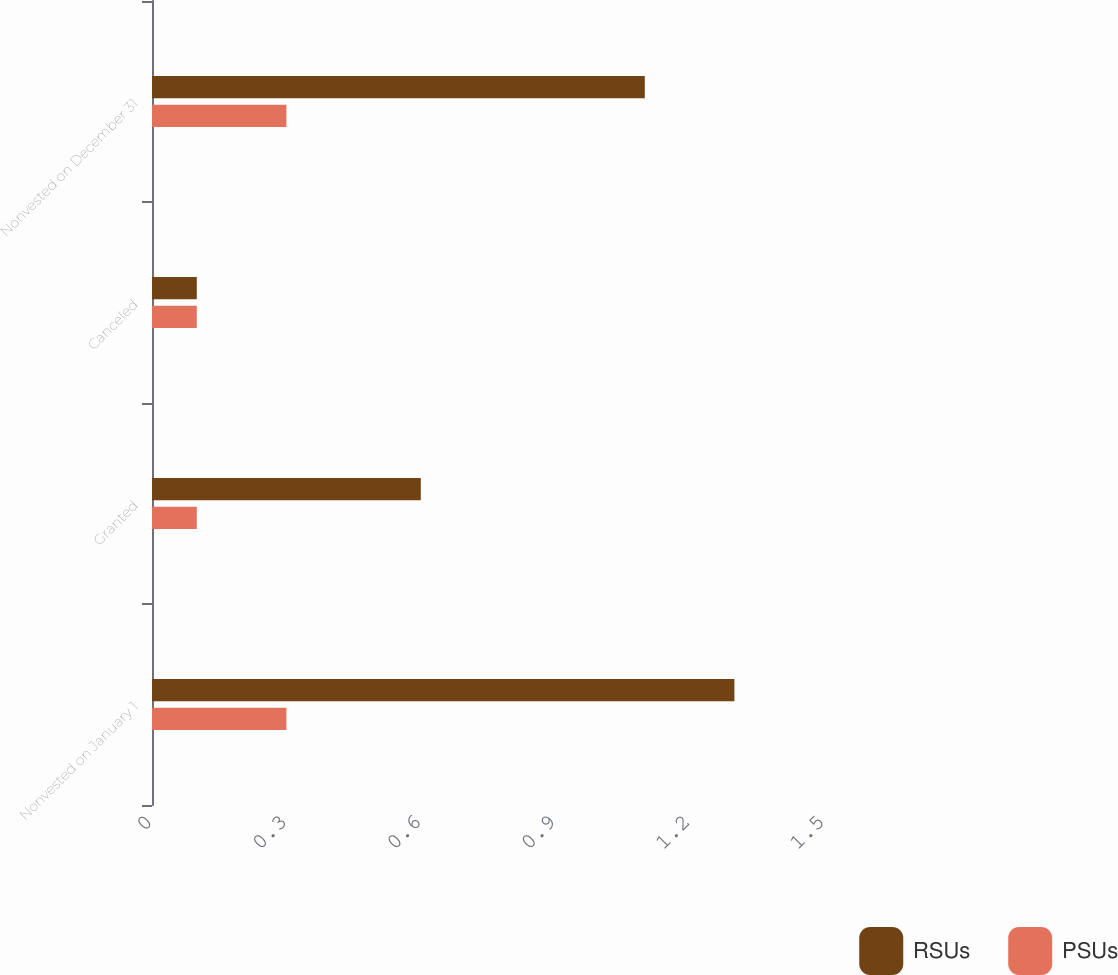<chart> <loc_0><loc_0><loc_500><loc_500><stacked_bar_chart><ecel><fcel>Nonvested on January 1<fcel>Granted<fcel>Canceled<fcel>Nonvested on December 31<nl><fcel>RSUs<fcel>1.3<fcel>0.6<fcel>0.1<fcel>1.1<nl><fcel>PSUs<fcel>0.3<fcel>0.1<fcel>0.1<fcel>0.3<nl></chart> 